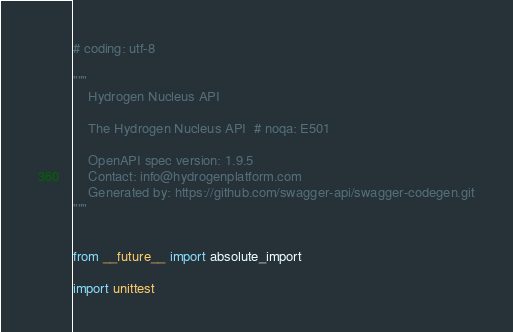<code> <loc_0><loc_0><loc_500><loc_500><_Python_># coding: utf-8

"""
    Hydrogen Nucleus API

    The Hydrogen Nucleus API  # noqa: E501

    OpenAPI spec version: 1.9.5
    Contact: info@hydrogenplatform.com
    Generated by: https://github.com/swagger-api/swagger-codegen.git
"""


from __future__ import absolute_import

import unittest
</code> 